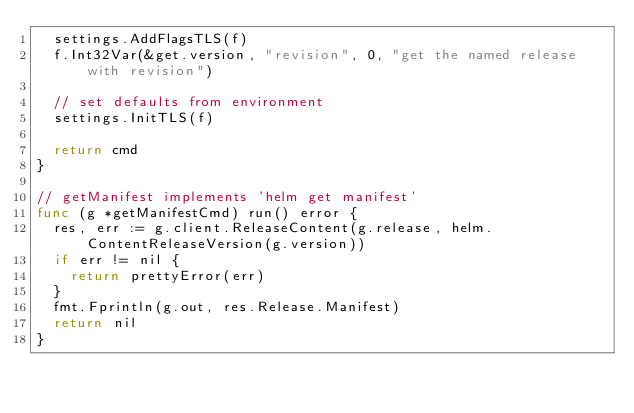<code> <loc_0><loc_0><loc_500><loc_500><_Go_>	settings.AddFlagsTLS(f)
	f.Int32Var(&get.version, "revision", 0, "get the named release with revision")

	// set defaults from environment
	settings.InitTLS(f)

	return cmd
}

// getManifest implements 'helm get manifest'
func (g *getManifestCmd) run() error {
	res, err := g.client.ReleaseContent(g.release, helm.ContentReleaseVersion(g.version))
	if err != nil {
		return prettyError(err)
	}
	fmt.Fprintln(g.out, res.Release.Manifest)
	return nil
}
</code> 